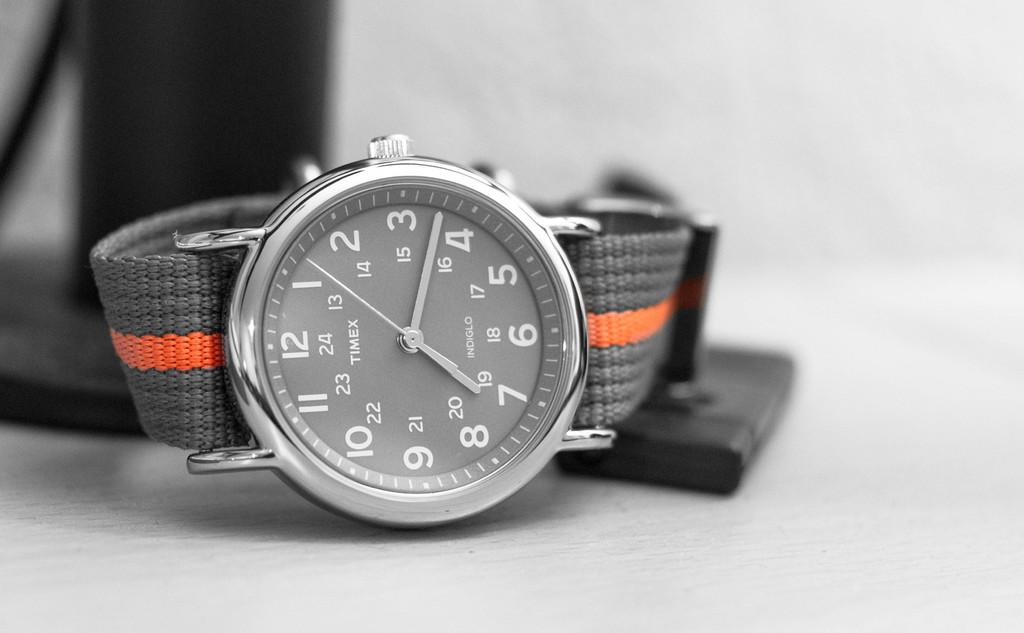<image>
Render a clear and concise summary of the photo. A watch shows that the current time is around 7:15. 